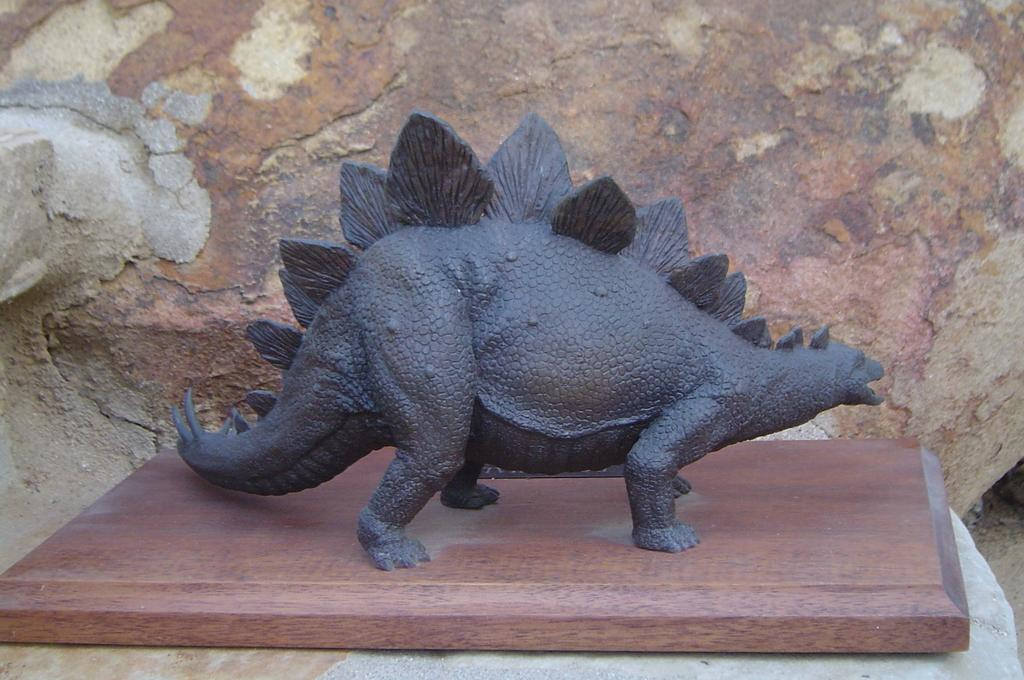What is the main subject of the image? There is a sculpture in the image. What does the sculpture resemble? The sculpture resembles a dinosaur. What is the sculpture placed on? The sculpture is on a wooden object. What can be seen in the background of the image? There is a well in the background of the image. How many balls are visible in the image? There are no balls present in the image. What type of skirt is worn by the dinosaur sculpture? The sculpture is of a dinosaur, which is an animal and does not wear clothing like a skirt. 